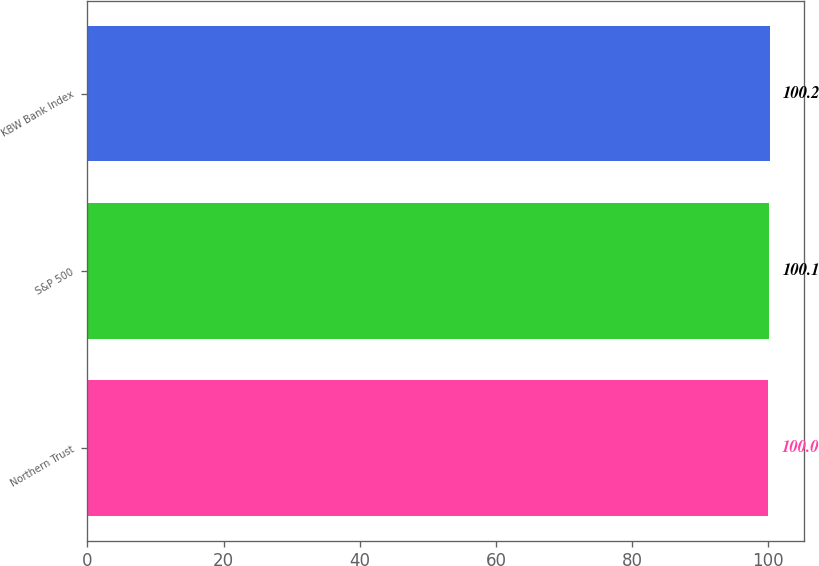Convert chart to OTSL. <chart><loc_0><loc_0><loc_500><loc_500><bar_chart><fcel>Northern Trust<fcel>S&P 500<fcel>KBW Bank Index<nl><fcel>100<fcel>100.1<fcel>100.2<nl></chart> 